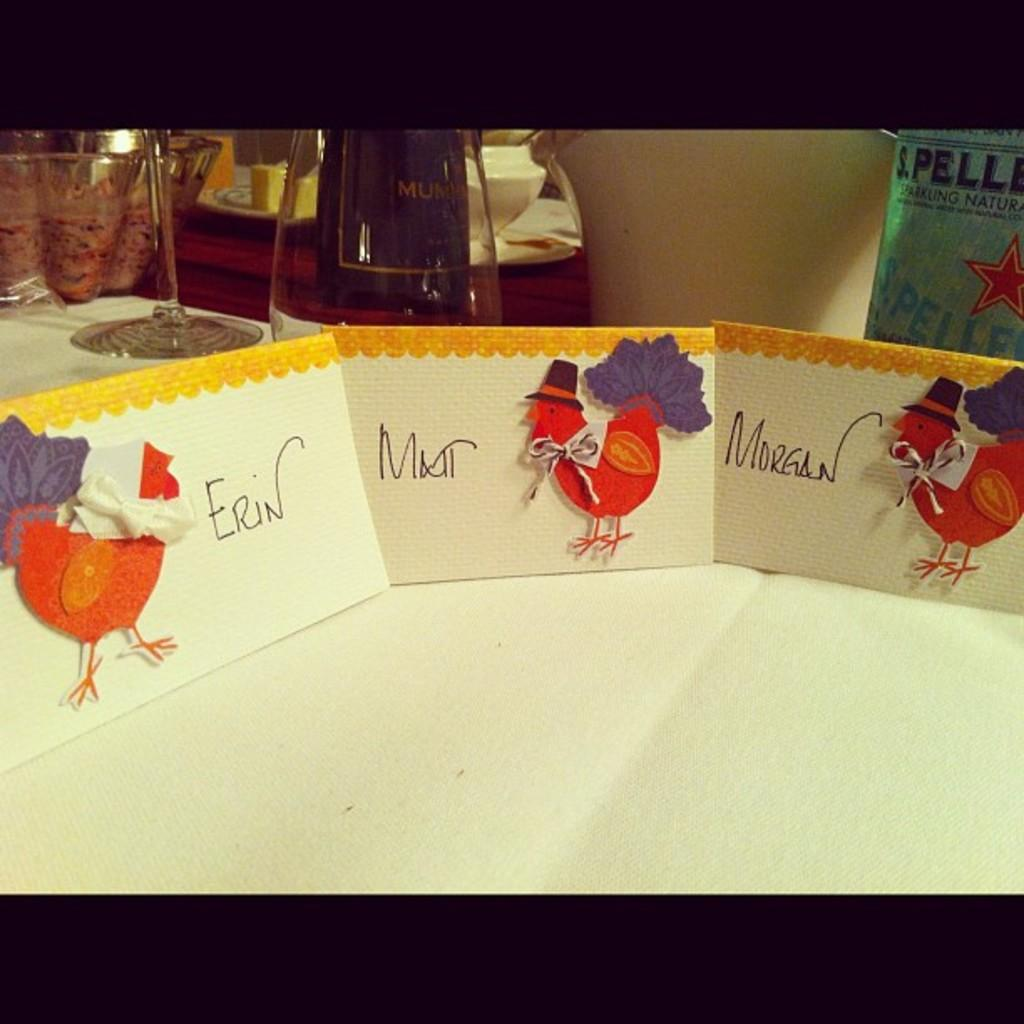Provide a one-sentence caption for the provided image. A group of three Thanksgiving cards for Erin, Matt and Morgan lined up on a table. 